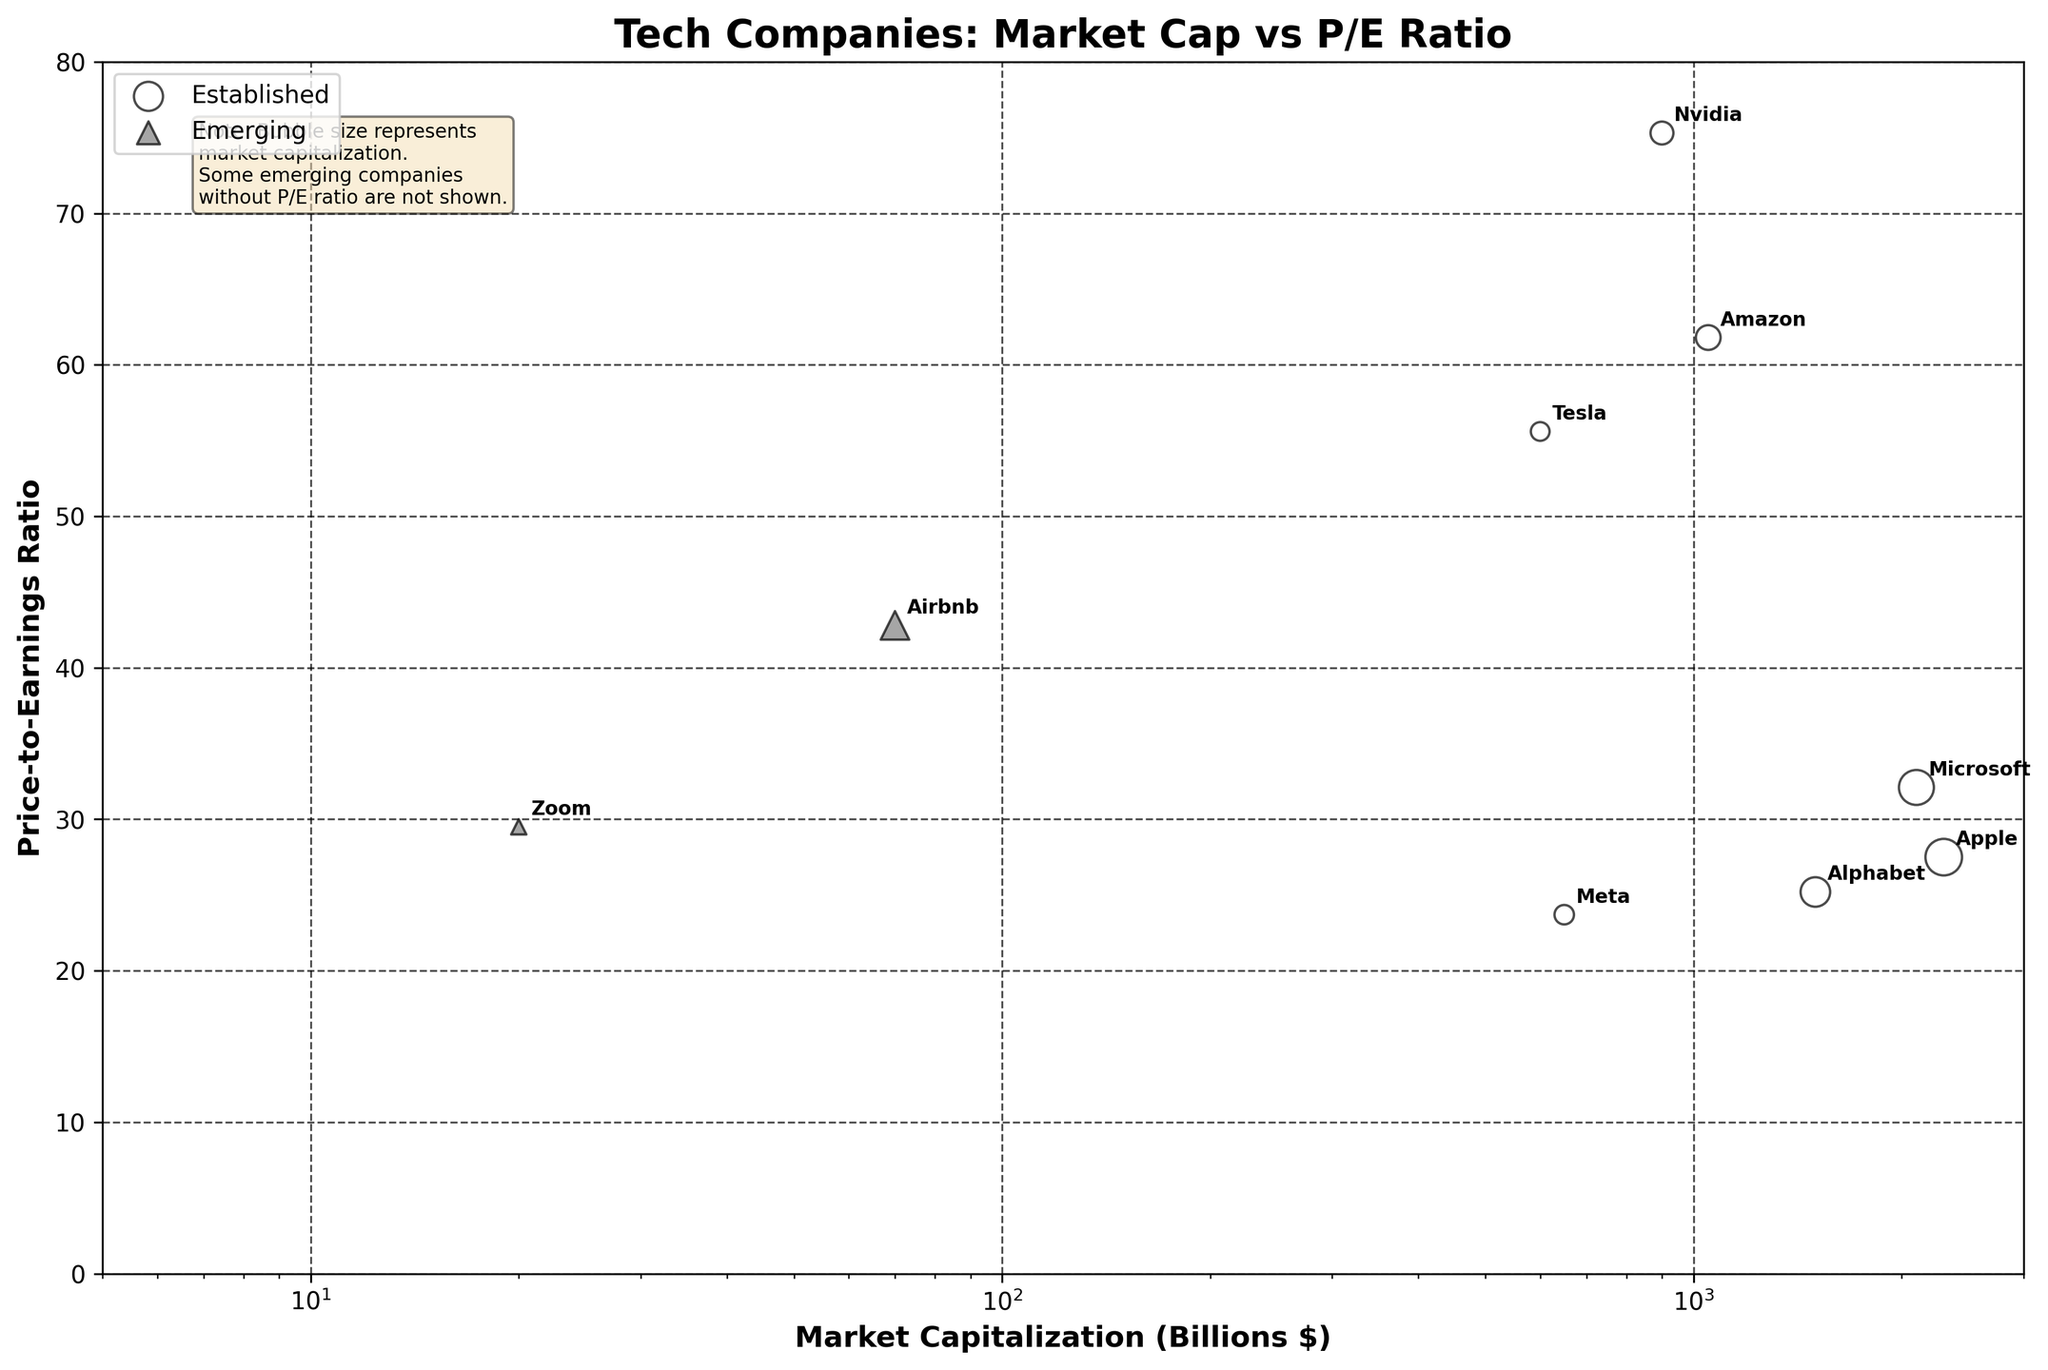Who has the highest P/E ratio among established companies? By looking at the circle markers representing established companies, Nvidia has the highest P/E ratio of 75.3.
Answer: Nvidia What is the difference in Market Capitalization between Apple and Microsoft? Apple has a Market Capitalization of 2300 billion dollars while Microsoft has 2100 billion dollars. The difference is 2300 - 2100 = 200 billion dollars.
Answer: 200 billion dollars How many established companies are in the plot? By counting the circle markers, there are 7 established companies plotted.
Answer: 7 What is the title of the figure? The title is written at the top of the figure, which is 'Tech Companies: Market Cap vs P/E Ratio'.
Answer: Tech Companies: Market Cap vs P/E Ratio Which established company has the lowest P/E ratio? By comparing the P/E ratios of all circle markers, Meta has the lowest P/E ratio of 23.7.
Answer: Meta Which company has the smallest market cap among the established ones, and what is its value? By reviewing the size of circle markers, the smallest belongs to Tesla with a Market Capitalization of 600 billion dollars.
Answer: Tesla, 600 billion dollars Is there a general trend in P/E ratios between established companies and emerging companies? Established companies generally have more varied P/E ratios, some high and some low, while emerging companies (which are plotted as triangles) have relatively fewer distinct P/E ratios given many have N/A. The established companies show a broader range of P/E values.
Answer: Established companies are more varied in P/E ratios Which company among the emerging ones has the highest P/E ratio? Among the triangle markers for emerging companies, Airbnb has the highest P/E ratio of 42.8.
Answer: Airbnb Within which range are the P/E ratios of established companies? By observing the distribution of circle markers for established companies along the Y-axis, their P/E ratios range from around 23.7 to 75.3.
Answer: Approximately 23.7 to 75.3 